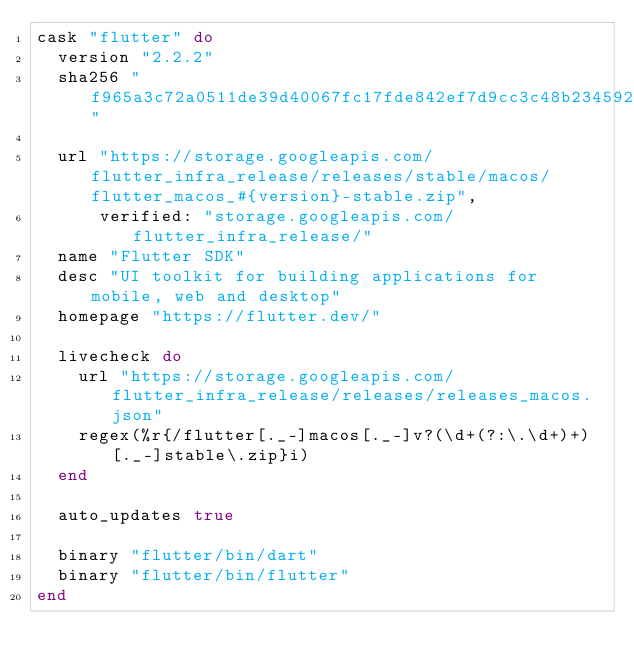<code> <loc_0><loc_0><loc_500><loc_500><_Ruby_>cask "flutter" do
  version "2.2.2"
  sha256 "f965a3c72a0511de39d40067fc17fde842ef7d9cc3c48b2345924d05ce4e8ef0"

  url "https://storage.googleapis.com/flutter_infra_release/releases/stable/macos/flutter_macos_#{version}-stable.zip",
      verified: "storage.googleapis.com/flutter_infra_release/"
  name "Flutter SDK"
  desc "UI toolkit for building applications for mobile, web and desktop"
  homepage "https://flutter.dev/"

  livecheck do
    url "https://storage.googleapis.com/flutter_infra_release/releases/releases_macos.json"
    regex(%r{/flutter[._-]macos[._-]v?(\d+(?:\.\d+)+)[._-]stable\.zip}i)
  end

  auto_updates true

  binary "flutter/bin/dart"
  binary "flutter/bin/flutter"
end
</code> 